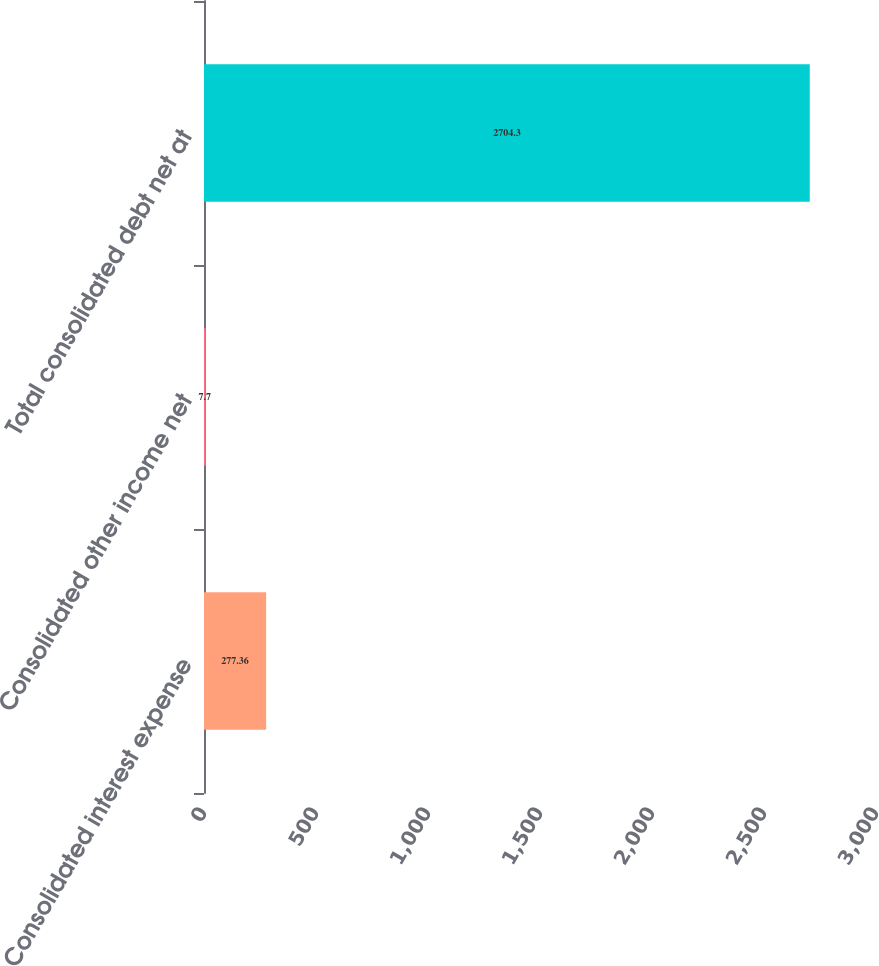Convert chart to OTSL. <chart><loc_0><loc_0><loc_500><loc_500><bar_chart><fcel>Consolidated interest expense<fcel>Consolidated other income net<fcel>Total consolidated debt net at<nl><fcel>277.36<fcel>7.7<fcel>2704.3<nl></chart> 